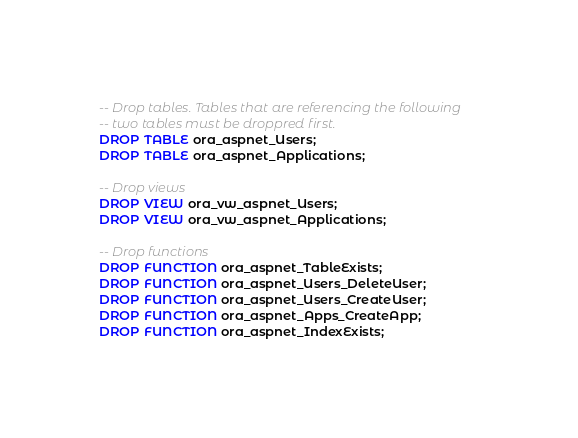Convert code to text. <code><loc_0><loc_0><loc_500><loc_500><_SQL_>
-- Drop tables. Tables that are referencing the following 
-- two tables must be droppred first.
DROP TABLE ora_aspnet_Users;
DROP TABLE ora_aspnet_Applications;

-- Drop views
DROP VIEW ora_vw_aspnet_Users;
DROP VIEW ora_vw_aspnet_Applications;

-- Drop functions
DROP FUNCTION ora_aspnet_TableExists;
DROP FUNCTION ora_aspnet_Users_DeleteUser;
DROP FUNCTION ora_aspnet_Users_CreateUser;
DROP FUNCTION ora_aspnet_Apps_CreateApp;
DROP FUNCTION ora_aspnet_IndexExists;
</code> 